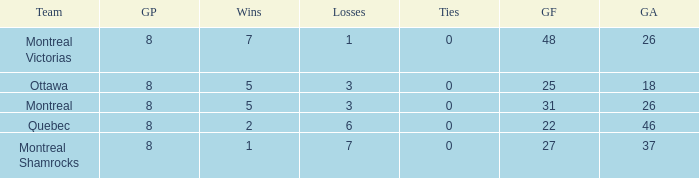For teams with more than 0 ties and goals against of 37, how many wins were tallied? None. 